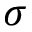Convert formula to latex. <formula><loc_0><loc_0><loc_500><loc_500>\sigma</formula> 